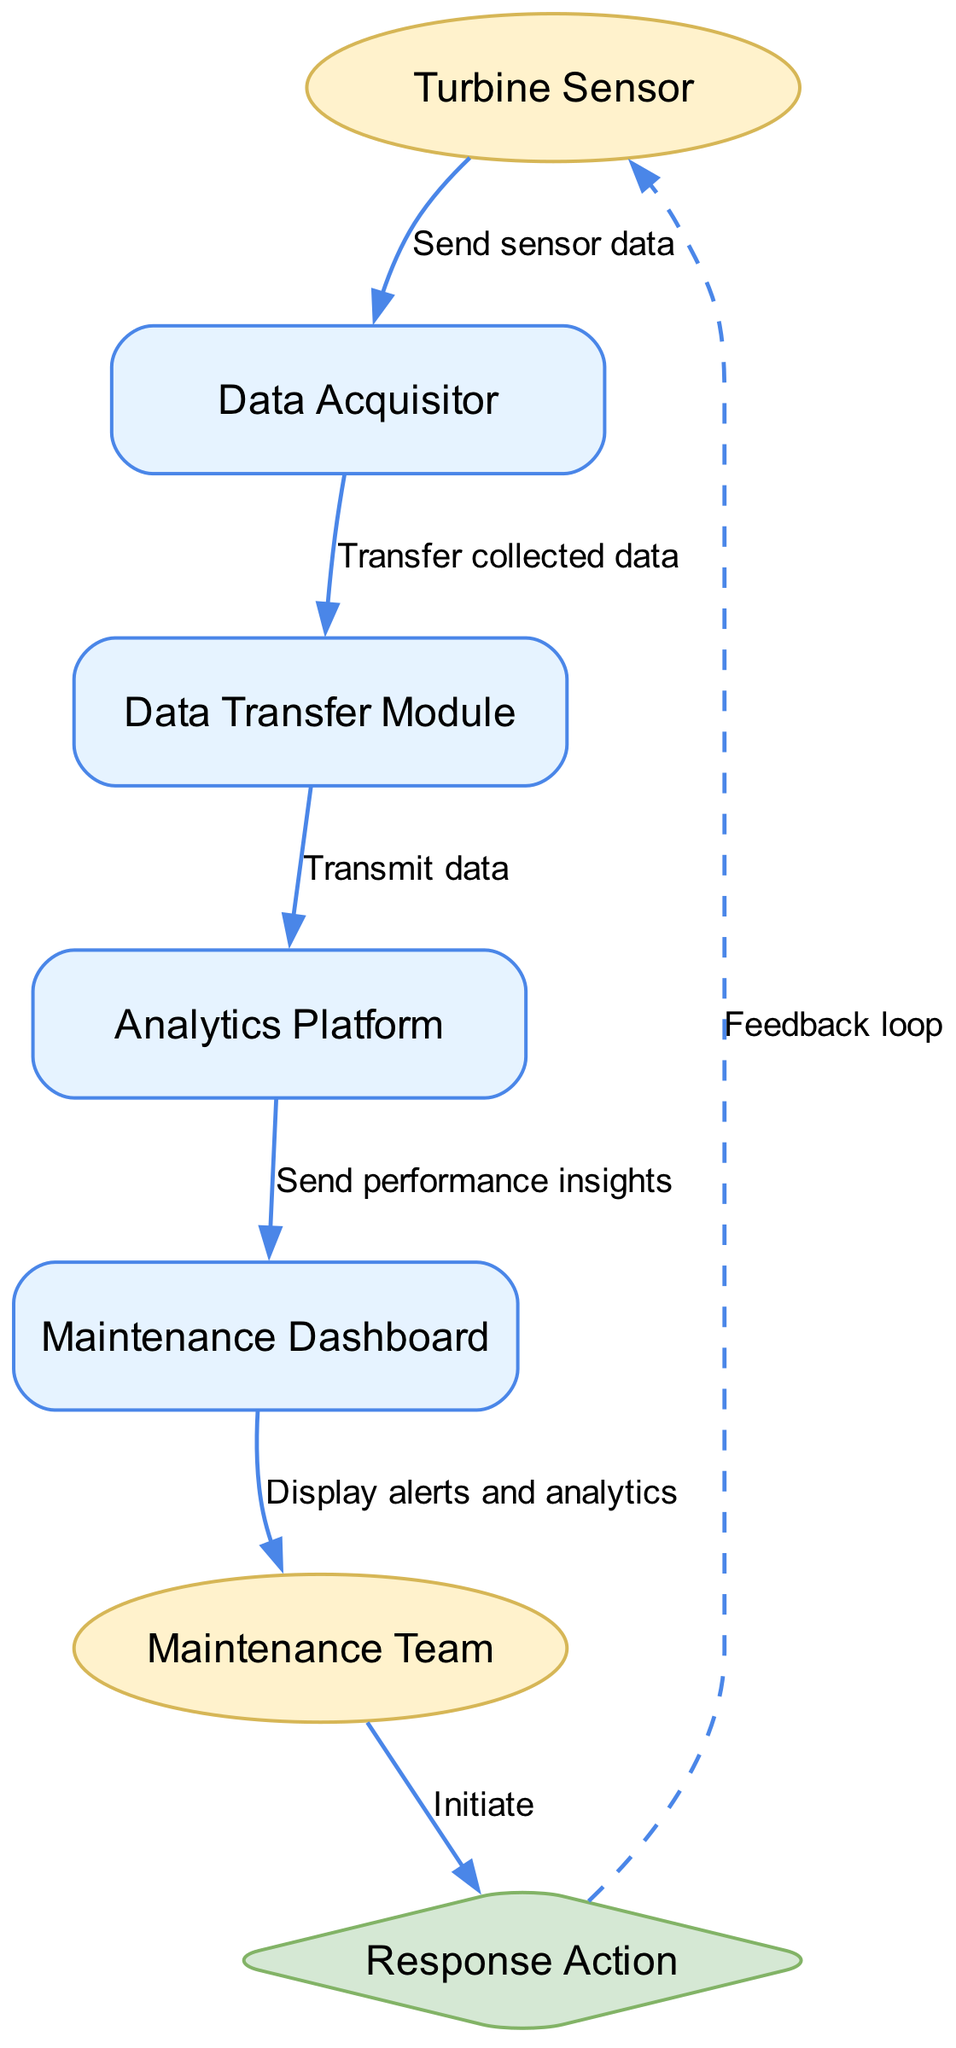What is the first component that receives data? The diagram indicates that the "Turbine Sensor" is the first actor that sends data, making it the initial component in the data flow.
Answer: Turbine Sensor How many components are involved in the data flow? The diagram shows four components: "Data Acquisitor," "Data Transfer Module," "Analytics Platform," and "Maintenance Dashboard," totaling four components in the data flow.
Answer: 4 What does the "Data Transfer Module" do? The diagram specifies that the "Data Transfer Module" is responsible for transmitting data to the analytics platform. This function is indicated within the flow of the sequence diagram.
Answer: Transmit data Who receives alerts from the "Maintenance Dashboard"? According to the diagram, the "Maintenance Team" is the actor that receives alerts displayed on the "Maintenance Dashboard." This indicates a direct connection between these two elements.
Answer: Maintenance Team What action does the "Maintenance Team" initiate after viewing analytics? The diagram indicates that after the "Maintenance Team" views analytics, they initiate a "Response Action," which is a direct consequence of the insights they receive.
Answer: Initiate What type of relationship exists between "Response Action" and "Turbine Sensor"? The diagram describes a dashed line indicating a feedback loop between "Response Action" and "Turbine Sensor," suggesting a cyclical or evaluative relationship that feeds back into the monitoring process.
Answer: Feedback loop Which component analyzes incoming data? The "Analytics Platform" is explicitly indicated in the diagram as the component that analyzes the incoming data for performance insights.
Answer: Analytics Platform What initiates the performance insights sent to the "Maintenance Dashboard"? The diagram shows that performance insights are sent to the "Maintenance Dashboard" from the "Analytics Platform," indicating that the analysis done here triggers the data flow to the dashboard.
Answer: Analytics Platform What is depicted as a critical action taken by the "Maintenance Team"? The "Response Action" is depicted as a critical action taken by the "Maintenance Team," which is based on the insights derived from the analytics, highlighting the team's responsibility in maintaining equipment performance.
Answer: Response Action 